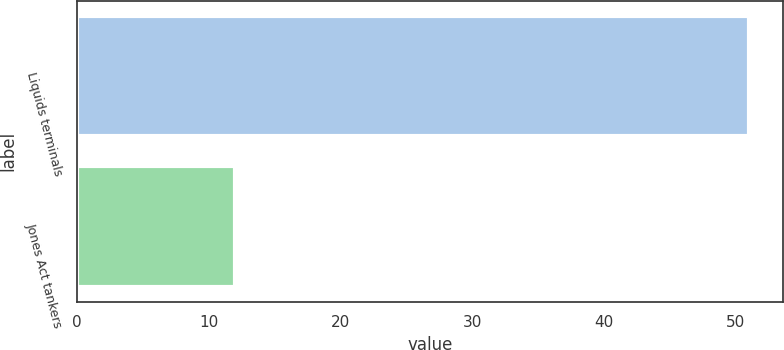<chart> <loc_0><loc_0><loc_500><loc_500><bar_chart><fcel>Liquids terminals<fcel>Jones Act tankers<nl><fcel>51<fcel>12<nl></chart> 